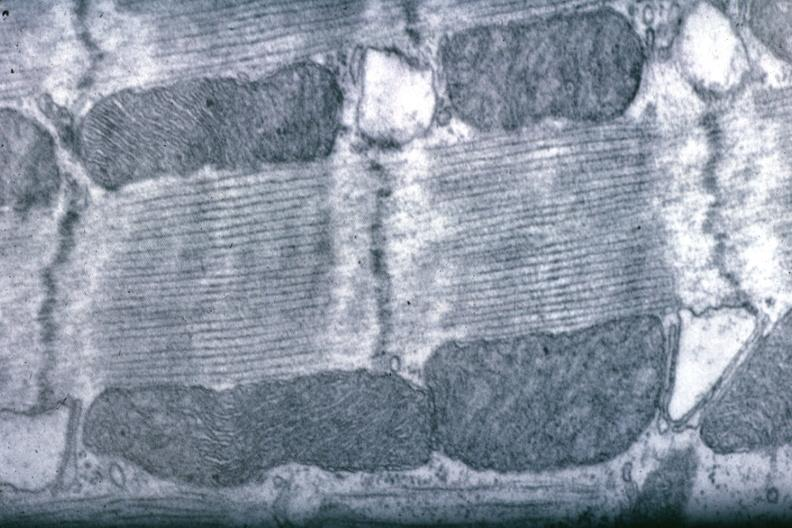s lower chest and abdomen anterior present?
Answer the question using a single word or phrase. No 